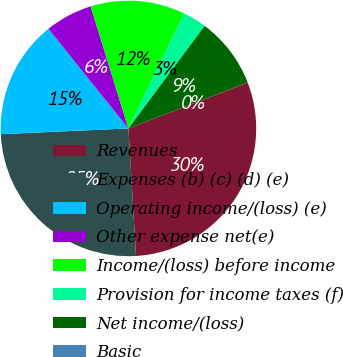Convert chart. <chart><loc_0><loc_0><loc_500><loc_500><pie_chart><fcel>Revenues<fcel>Expenses (b) (c) (d) (e)<fcel>Operating income/(loss) (e)<fcel>Other expense net(e)<fcel>Income/(loss) before income<fcel>Provision for income taxes (f)<fcel>Net income/(loss)<fcel>Basic<nl><fcel>29.9%<fcel>25.23%<fcel>14.95%<fcel>5.99%<fcel>11.96%<fcel>3.0%<fcel>8.97%<fcel>0.01%<nl></chart> 